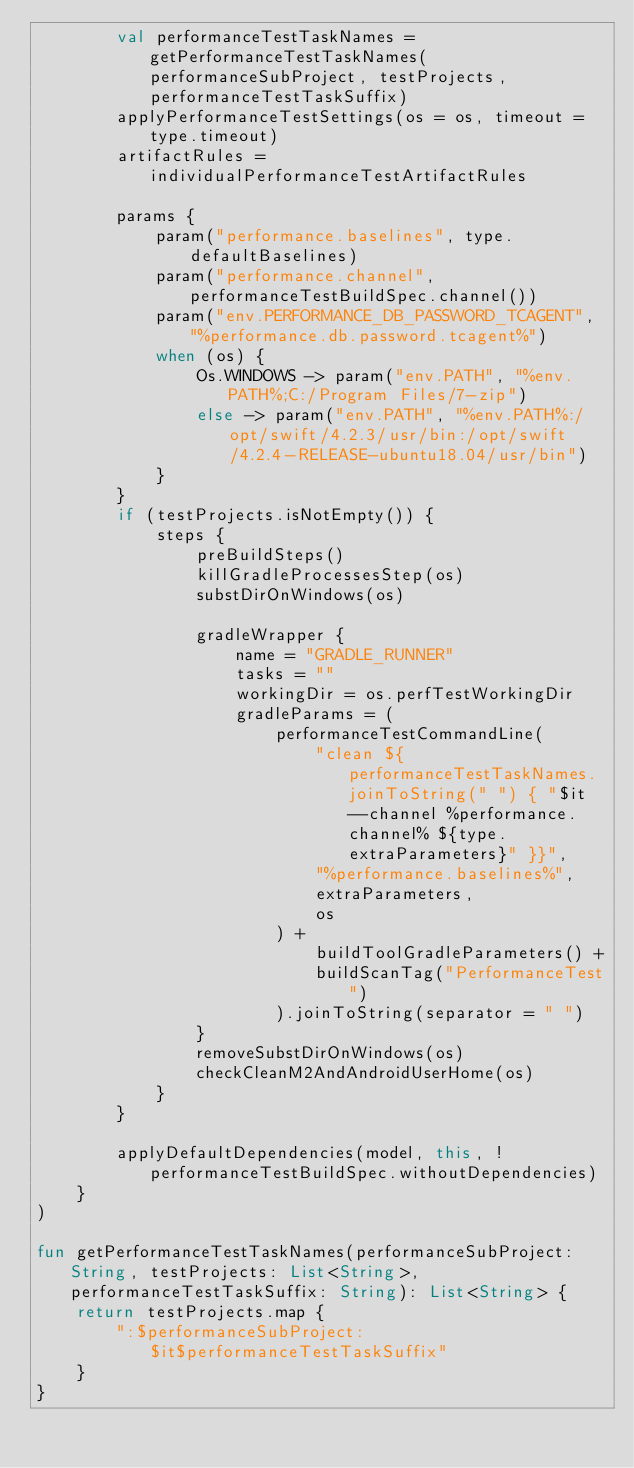<code> <loc_0><loc_0><loc_500><loc_500><_Kotlin_>        val performanceTestTaskNames = getPerformanceTestTaskNames(performanceSubProject, testProjects, performanceTestTaskSuffix)
        applyPerformanceTestSettings(os = os, timeout = type.timeout)
        artifactRules = individualPerformanceTestArtifactRules

        params {
            param("performance.baselines", type.defaultBaselines)
            param("performance.channel", performanceTestBuildSpec.channel())
            param("env.PERFORMANCE_DB_PASSWORD_TCAGENT", "%performance.db.password.tcagent%")
            when (os) {
                Os.WINDOWS -> param("env.PATH", "%env.PATH%;C:/Program Files/7-zip")
                else -> param("env.PATH", "%env.PATH%:/opt/swift/4.2.3/usr/bin:/opt/swift/4.2.4-RELEASE-ubuntu18.04/usr/bin")
            }
        }
        if (testProjects.isNotEmpty()) {
            steps {
                preBuildSteps()
                killGradleProcessesStep(os)
                substDirOnWindows(os)

                gradleWrapper {
                    name = "GRADLE_RUNNER"
                    tasks = ""
                    workingDir = os.perfTestWorkingDir
                    gradleParams = (
                        performanceTestCommandLine(
                            "clean ${performanceTestTaskNames.joinToString(" ") { "$it --channel %performance.channel% ${type.extraParameters}" }}",
                            "%performance.baselines%",
                            extraParameters,
                            os
                        ) +
                            buildToolGradleParameters() +
                            buildScanTag("PerformanceTest")
                        ).joinToString(separator = " ")
                }
                removeSubstDirOnWindows(os)
                checkCleanM2AndAndroidUserHome(os)
            }
        }

        applyDefaultDependencies(model, this, !performanceTestBuildSpec.withoutDependencies)
    }
)

fun getPerformanceTestTaskNames(performanceSubProject: String, testProjects: List<String>, performanceTestTaskSuffix: String): List<String> {
    return testProjects.map {
        ":$performanceSubProject:$it$performanceTestTaskSuffix"
    }
}
</code> 